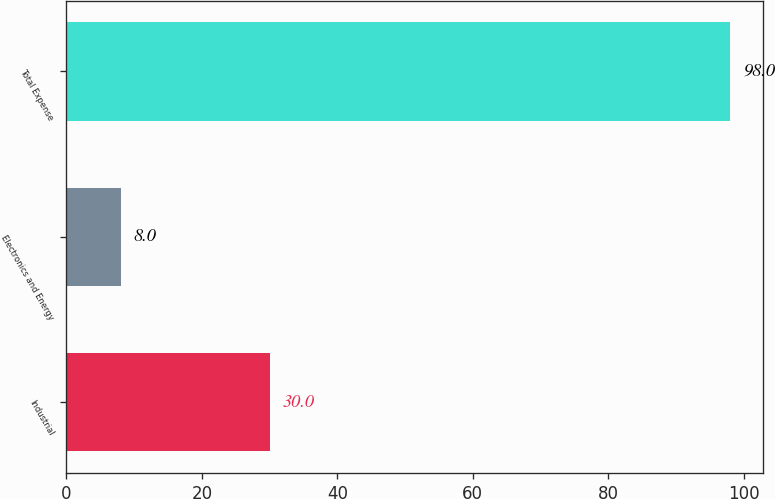<chart> <loc_0><loc_0><loc_500><loc_500><bar_chart><fcel>Industrial<fcel>Electronics and Energy<fcel>Total Expense<nl><fcel>30<fcel>8<fcel>98<nl></chart> 